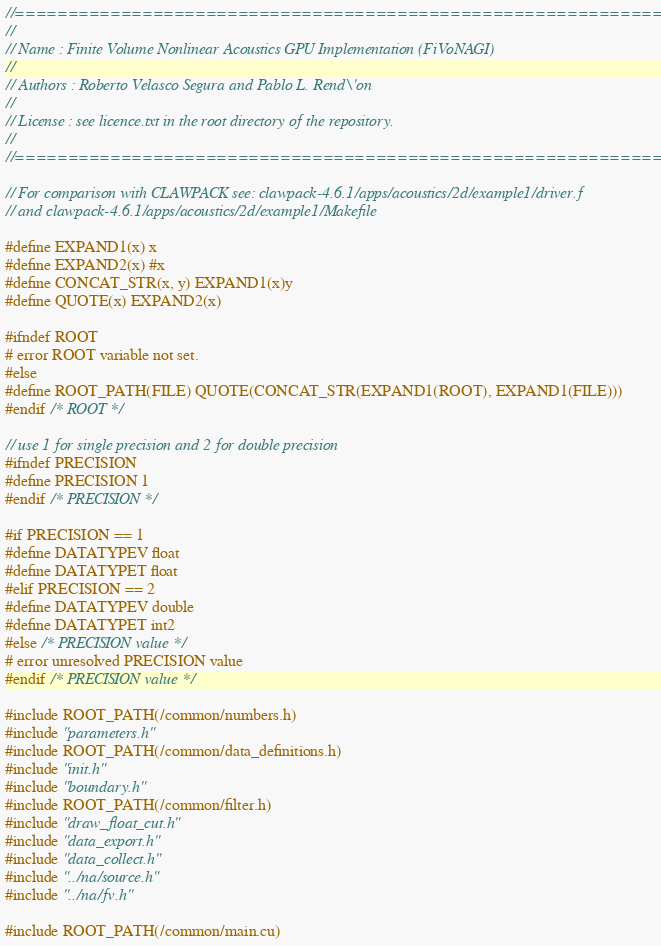Convert code to text. <code><loc_0><loc_0><loc_500><loc_500><_Cuda_>//=======================================================================
//
// Name : Finite Volume Nonlinear Acoustics GPU Implementation (FiVoNAGI)
//
// Authors : Roberto Velasco Segura and Pablo L. Rend\'on
//
// License : see licence.txt in the root directory of the repository.
//
//=======================================================================

// For comparison with CLAWPACK see: clawpack-4.6.1/apps/acoustics/2d/example1/driver.f
// and clawpack-4.6.1/apps/acoustics/2d/example1/Makefile

#define EXPAND1(x) x
#define EXPAND2(x) #x
#define CONCAT_STR(x, y) EXPAND1(x)y
#define QUOTE(x) EXPAND2(x)

#ifndef ROOT
# error ROOT variable not set.
#else
#define ROOT_PATH(FILE) QUOTE(CONCAT_STR(EXPAND1(ROOT), EXPAND1(FILE)))
#endif /* ROOT */

// use 1 for single precision and 2 for double precision
#ifndef PRECISION
#define PRECISION 1
#endif /* PRECISION */

#if PRECISION == 1 
#define DATATYPEV float
#define DATATYPET float
#elif PRECISION == 2
#define DATATYPEV double
#define DATATYPET int2
#else /* PRECISION value */
# error unresolved PRECISION value
#endif /* PRECISION value */

#include ROOT_PATH(/common/numbers.h)
#include "parameters.h"
#include ROOT_PATH(/common/data_definitions.h)
#include "init.h"
#include "boundary.h"
#include ROOT_PATH(/common/filter.h)
#include "draw_float_cut.h"
#include "data_export.h"
#include "data_collect.h"
#include "../na/source.h"
#include "../na/fv.h"

#include ROOT_PATH(/common/main.cu)
</code> 